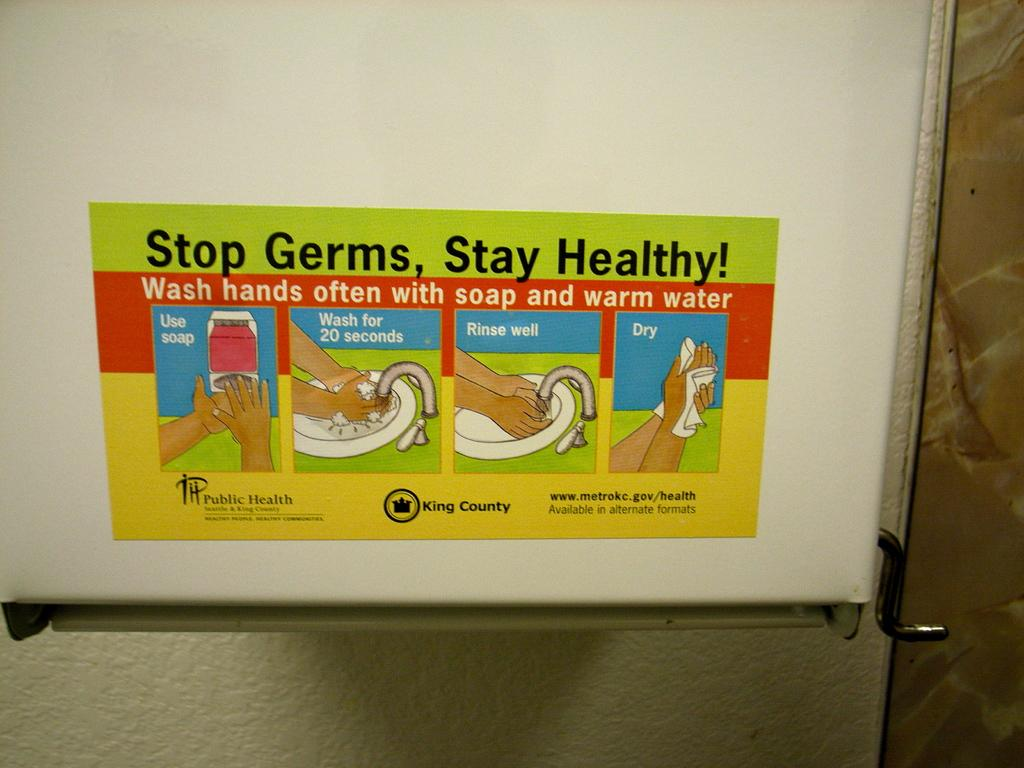<image>
Render a clear and concise summary of the photo. Poster on wall advertising to stop germs, and stay healthy 